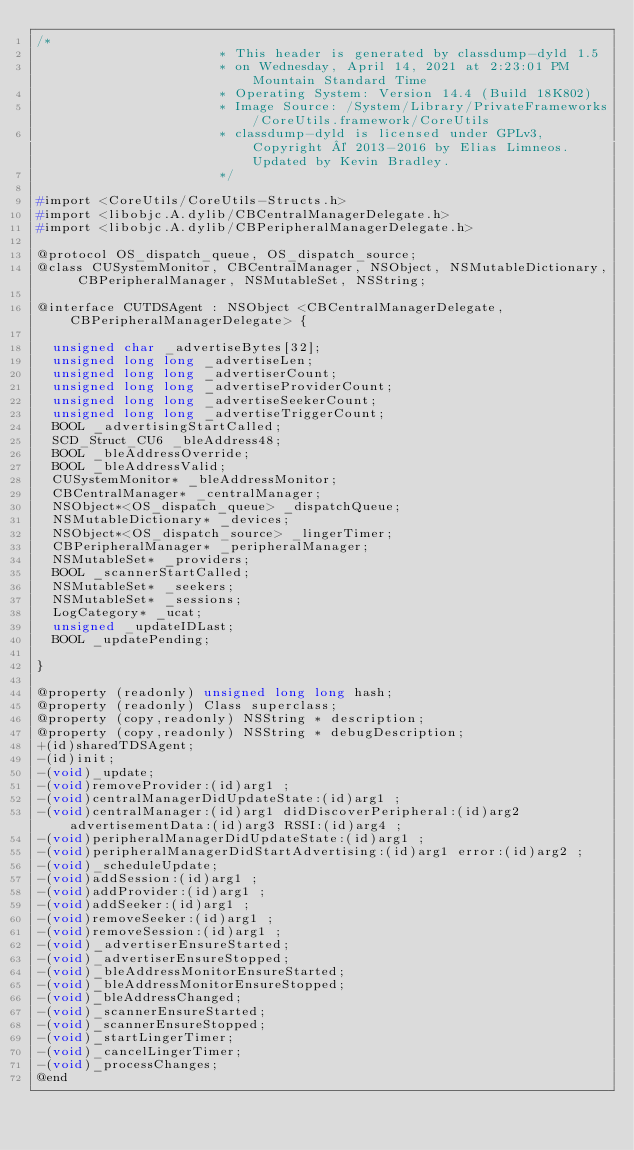<code> <loc_0><loc_0><loc_500><loc_500><_C_>/*
                       * This header is generated by classdump-dyld 1.5
                       * on Wednesday, April 14, 2021 at 2:23:01 PM Mountain Standard Time
                       * Operating System: Version 14.4 (Build 18K802)
                       * Image Source: /System/Library/PrivateFrameworks/CoreUtils.framework/CoreUtils
                       * classdump-dyld is licensed under GPLv3, Copyright © 2013-2016 by Elias Limneos. Updated by Kevin Bradley.
                       */

#import <CoreUtils/CoreUtils-Structs.h>
#import <libobjc.A.dylib/CBCentralManagerDelegate.h>
#import <libobjc.A.dylib/CBPeripheralManagerDelegate.h>

@protocol OS_dispatch_queue, OS_dispatch_source;
@class CUSystemMonitor, CBCentralManager, NSObject, NSMutableDictionary, CBPeripheralManager, NSMutableSet, NSString;

@interface CUTDSAgent : NSObject <CBCentralManagerDelegate, CBPeripheralManagerDelegate> {

	unsigned char _advertiseBytes[32];
	unsigned long long _advertiseLen;
	unsigned long long _advertiserCount;
	unsigned long long _advertiseProviderCount;
	unsigned long long _advertiseSeekerCount;
	unsigned long long _advertiseTriggerCount;
	BOOL _advertisingStartCalled;
	SCD_Struct_CU6 _bleAddress48;
	BOOL _bleAddressOverride;
	BOOL _bleAddressValid;
	CUSystemMonitor* _bleAddressMonitor;
	CBCentralManager* _centralManager;
	NSObject*<OS_dispatch_queue> _dispatchQueue;
	NSMutableDictionary* _devices;
	NSObject*<OS_dispatch_source> _lingerTimer;
	CBPeripheralManager* _peripheralManager;
	NSMutableSet* _providers;
	BOOL _scannerStartCalled;
	NSMutableSet* _seekers;
	NSMutableSet* _sessions;
	LogCategory* _ucat;
	unsigned _updateIDLast;
	BOOL _updatePending;

}

@property (readonly) unsigned long long hash; 
@property (readonly) Class superclass; 
@property (copy,readonly) NSString * description; 
@property (copy,readonly) NSString * debugDescription; 
+(id)sharedTDSAgent;
-(id)init;
-(void)_update;
-(void)removeProvider:(id)arg1 ;
-(void)centralManagerDidUpdateState:(id)arg1 ;
-(void)centralManager:(id)arg1 didDiscoverPeripheral:(id)arg2 advertisementData:(id)arg3 RSSI:(id)arg4 ;
-(void)peripheralManagerDidUpdateState:(id)arg1 ;
-(void)peripheralManagerDidStartAdvertising:(id)arg1 error:(id)arg2 ;
-(void)_scheduleUpdate;
-(void)addSession:(id)arg1 ;
-(void)addProvider:(id)arg1 ;
-(void)addSeeker:(id)arg1 ;
-(void)removeSeeker:(id)arg1 ;
-(void)removeSession:(id)arg1 ;
-(void)_advertiserEnsureStarted;
-(void)_advertiserEnsureStopped;
-(void)_bleAddressMonitorEnsureStarted;
-(void)_bleAddressMonitorEnsureStopped;
-(void)_bleAddressChanged;
-(void)_scannerEnsureStarted;
-(void)_scannerEnsureStopped;
-(void)_startLingerTimer;
-(void)_cancelLingerTimer;
-(void)_processChanges;
@end

</code> 